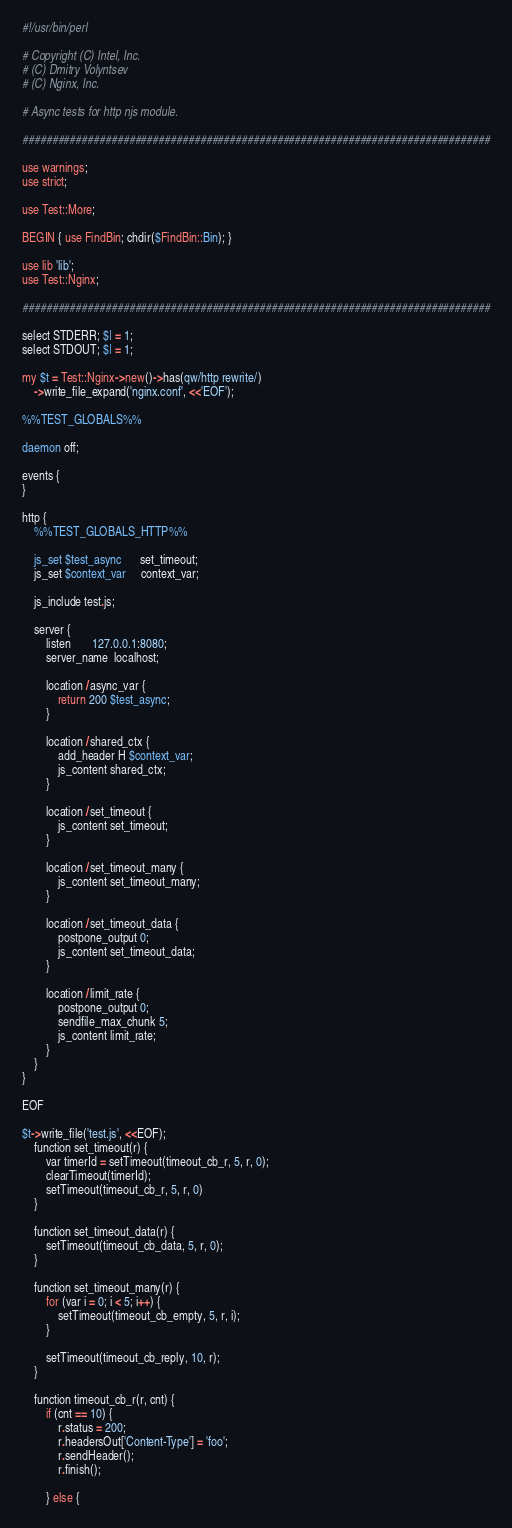<code> <loc_0><loc_0><loc_500><loc_500><_Perl_>#!/usr/bin/perl

# Copyright (C) Intel, Inc.
# (C) Dmitry Volyntsev
# (C) Nginx, Inc.

# Async tests for http njs module.

###############################################################################

use warnings;
use strict;

use Test::More;

BEGIN { use FindBin; chdir($FindBin::Bin); }

use lib 'lib';
use Test::Nginx;

###############################################################################

select STDERR; $| = 1;
select STDOUT; $| = 1;

my $t = Test::Nginx->new()->has(qw/http rewrite/)
    ->write_file_expand('nginx.conf', <<'EOF');

%%TEST_GLOBALS%%

daemon off;

events {
}

http {
    %%TEST_GLOBALS_HTTP%%

    js_set $test_async      set_timeout;
    js_set $context_var     context_var;

    js_include test.js;

    server {
        listen       127.0.0.1:8080;
        server_name  localhost;

        location /async_var {
            return 200 $test_async;
        }

        location /shared_ctx {
            add_header H $context_var;
            js_content shared_ctx;
        }

        location /set_timeout {
            js_content set_timeout;
        }

        location /set_timeout_many {
            js_content set_timeout_many;
        }

        location /set_timeout_data {
            postpone_output 0;
            js_content set_timeout_data;
        }

        location /limit_rate {
            postpone_output 0;
            sendfile_max_chunk 5;
            js_content limit_rate;
        }
    }
}

EOF

$t->write_file('test.js', <<EOF);
    function set_timeout(r) {
        var timerId = setTimeout(timeout_cb_r, 5, r, 0);
        clearTimeout(timerId);
        setTimeout(timeout_cb_r, 5, r, 0)
    }

    function set_timeout_data(r) {
        setTimeout(timeout_cb_data, 5, r, 0);
    }

    function set_timeout_many(r) {
        for (var i = 0; i < 5; i++) {
            setTimeout(timeout_cb_empty, 5, r, i);
        }

        setTimeout(timeout_cb_reply, 10, r);
    }

    function timeout_cb_r(r, cnt) {
        if (cnt == 10) {
            r.status = 200;
            r.headersOut['Content-Type'] = 'foo';
            r.sendHeader();
            r.finish();

        } else {</code> 